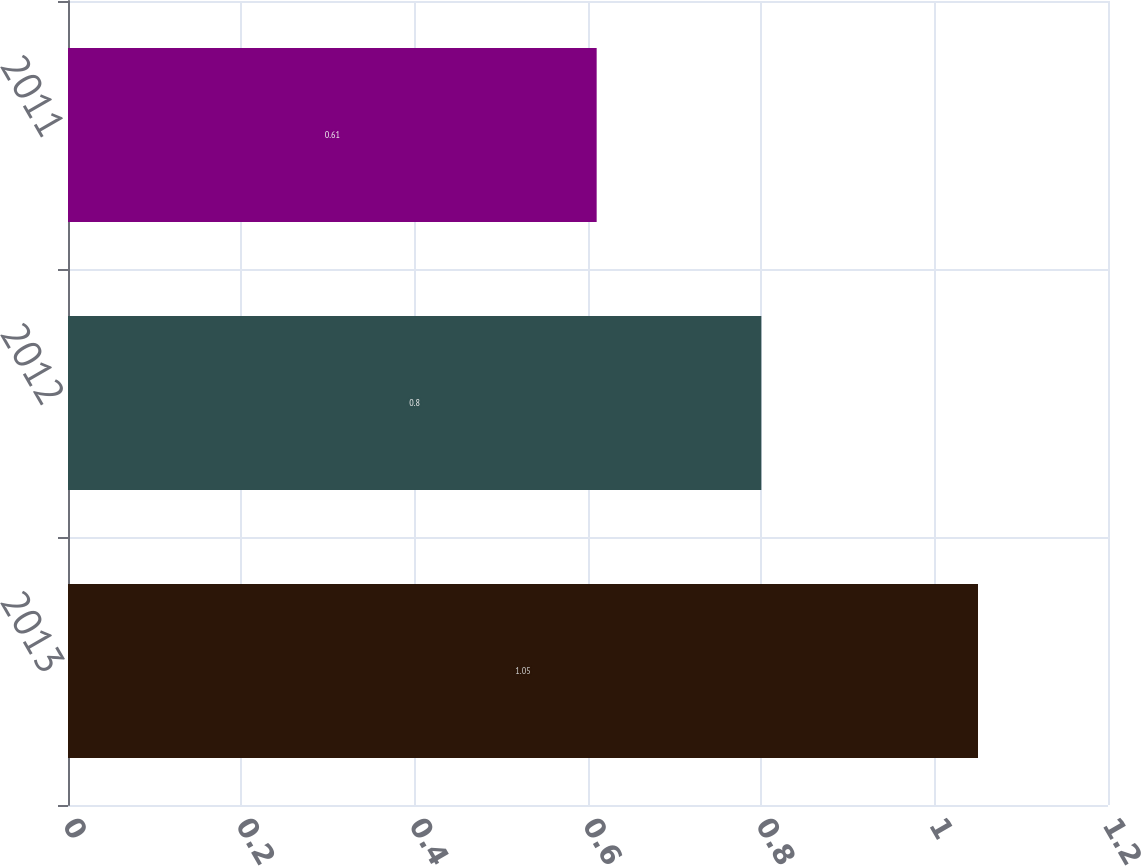Convert chart to OTSL. <chart><loc_0><loc_0><loc_500><loc_500><bar_chart><fcel>2013<fcel>2012<fcel>2011<nl><fcel>1.05<fcel>0.8<fcel>0.61<nl></chart> 